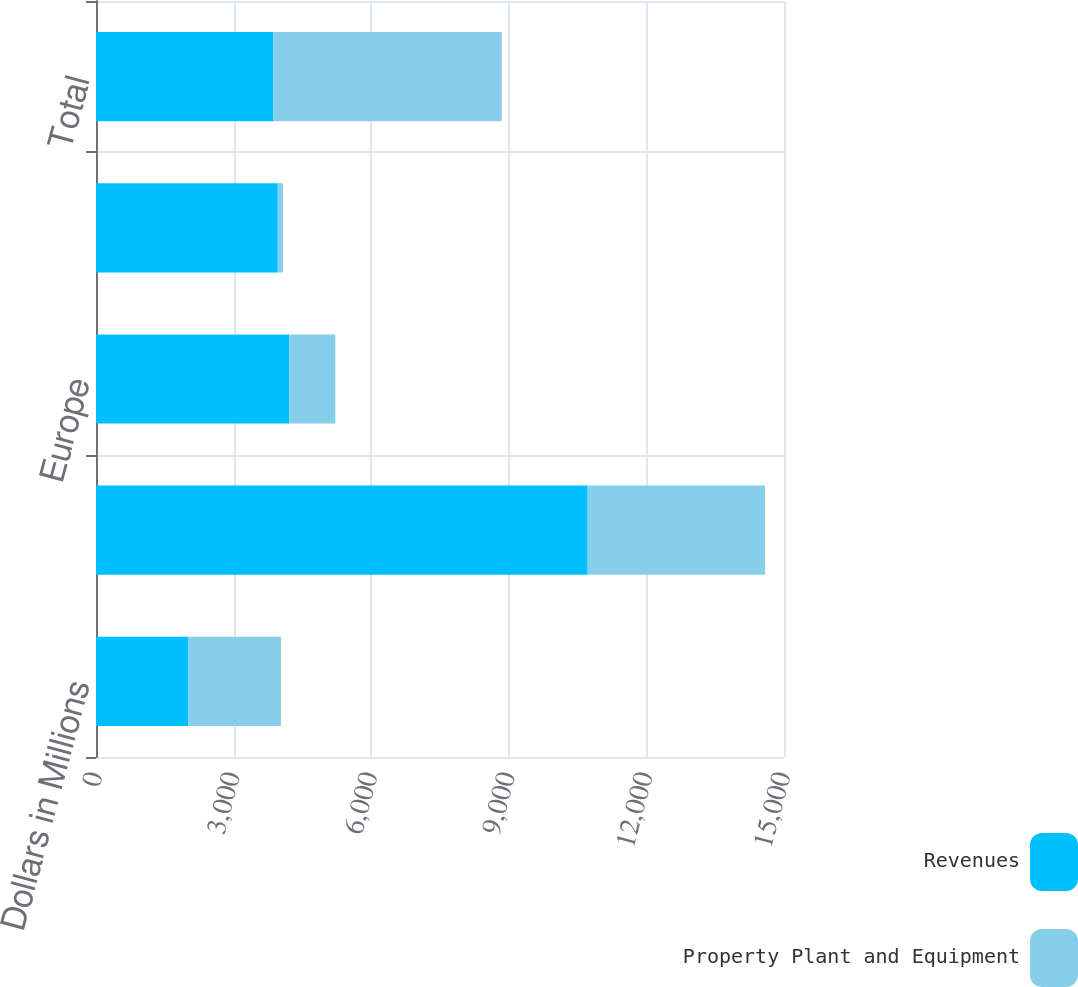Convert chart to OTSL. <chart><loc_0><loc_0><loc_500><loc_500><stacked_bar_chart><ecel><fcel>Dollars in Millions<fcel>United States<fcel>Europe<fcel>Rest of the World (a)<fcel>Total<nl><fcel>Revenues<fcel>2016<fcel>10720<fcel>4215<fcel>3964<fcel>3865<nl><fcel>Property Plant and Equipment<fcel>2016<fcel>3865<fcel>1003<fcel>112<fcel>4980<nl></chart> 